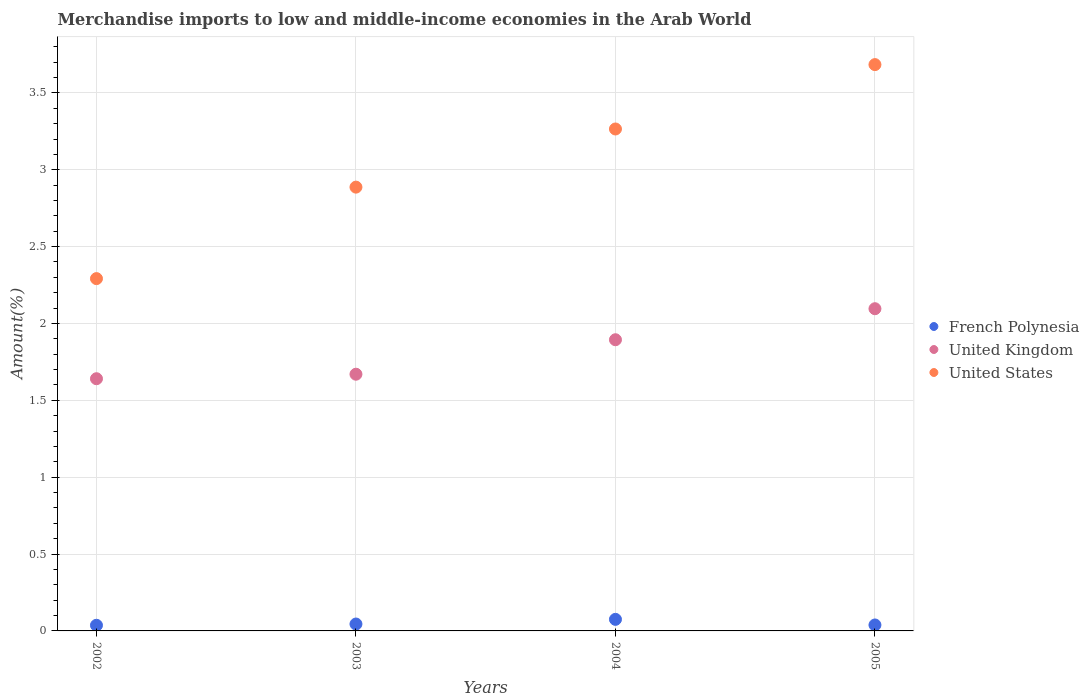What is the percentage of amount earned from merchandise imports in French Polynesia in 2002?
Provide a short and direct response. 0.04. Across all years, what is the maximum percentage of amount earned from merchandise imports in French Polynesia?
Offer a terse response. 0.08. Across all years, what is the minimum percentage of amount earned from merchandise imports in French Polynesia?
Provide a succinct answer. 0.04. In which year was the percentage of amount earned from merchandise imports in United Kingdom maximum?
Ensure brevity in your answer.  2005. What is the total percentage of amount earned from merchandise imports in United Kingdom in the graph?
Offer a terse response. 7.3. What is the difference between the percentage of amount earned from merchandise imports in United Kingdom in 2002 and that in 2004?
Offer a terse response. -0.25. What is the difference between the percentage of amount earned from merchandise imports in United States in 2004 and the percentage of amount earned from merchandise imports in French Polynesia in 2002?
Your response must be concise. 3.23. What is the average percentage of amount earned from merchandise imports in United Kingdom per year?
Your answer should be very brief. 1.83. In the year 2003, what is the difference between the percentage of amount earned from merchandise imports in United States and percentage of amount earned from merchandise imports in United Kingdom?
Offer a very short reply. 1.22. In how many years, is the percentage of amount earned from merchandise imports in United Kingdom greater than 0.9 %?
Ensure brevity in your answer.  4. What is the ratio of the percentage of amount earned from merchandise imports in French Polynesia in 2002 to that in 2003?
Offer a very short reply. 0.82. Is the difference between the percentage of amount earned from merchandise imports in United States in 2003 and 2004 greater than the difference between the percentage of amount earned from merchandise imports in United Kingdom in 2003 and 2004?
Offer a very short reply. No. What is the difference between the highest and the second highest percentage of amount earned from merchandise imports in French Polynesia?
Your response must be concise. 0.03. What is the difference between the highest and the lowest percentage of amount earned from merchandise imports in United States?
Keep it short and to the point. 1.39. Is the sum of the percentage of amount earned from merchandise imports in United States in 2003 and 2004 greater than the maximum percentage of amount earned from merchandise imports in French Polynesia across all years?
Ensure brevity in your answer.  Yes. Is it the case that in every year, the sum of the percentage of amount earned from merchandise imports in United Kingdom and percentage of amount earned from merchandise imports in French Polynesia  is greater than the percentage of amount earned from merchandise imports in United States?
Your answer should be compact. No. Is the percentage of amount earned from merchandise imports in United Kingdom strictly greater than the percentage of amount earned from merchandise imports in French Polynesia over the years?
Ensure brevity in your answer.  Yes. Is the percentage of amount earned from merchandise imports in United States strictly less than the percentage of amount earned from merchandise imports in United Kingdom over the years?
Keep it short and to the point. No. How many dotlines are there?
Give a very brief answer. 3. How many years are there in the graph?
Provide a succinct answer. 4. Does the graph contain grids?
Give a very brief answer. Yes. Where does the legend appear in the graph?
Keep it short and to the point. Center right. What is the title of the graph?
Your answer should be compact. Merchandise imports to low and middle-income economies in the Arab World. What is the label or title of the Y-axis?
Offer a very short reply. Amount(%). What is the Amount(%) of French Polynesia in 2002?
Provide a succinct answer. 0.04. What is the Amount(%) of United Kingdom in 2002?
Provide a succinct answer. 1.64. What is the Amount(%) in United States in 2002?
Your answer should be very brief. 2.29. What is the Amount(%) of French Polynesia in 2003?
Your answer should be very brief. 0.04. What is the Amount(%) of United Kingdom in 2003?
Provide a short and direct response. 1.67. What is the Amount(%) in United States in 2003?
Provide a succinct answer. 2.89. What is the Amount(%) in French Polynesia in 2004?
Offer a terse response. 0.08. What is the Amount(%) in United Kingdom in 2004?
Make the answer very short. 1.89. What is the Amount(%) in United States in 2004?
Offer a very short reply. 3.27. What is the Amount(%) in French Polynesia in 2005?
Give a very brief answer. 0.04. What is the Amount(%) of United Kingdom in 2005?
Provide a short and direct response. 2.1. What is the Amount(%) in United States in 2005?
Make the answer very short. 3.68. Across all years, what is the maximum Amount(%) of French Polynesia?
Keep it short and to the point. 0.08. Across all years, what is the maximum Amount(%) in United Kingdom?
Ensure brevity in your answer.  2.1. Across all years, what is the maximum Amount(%) of United States?
Ensure brevity in your answer.  3.68. Across all years, what is the minimum Amount(%) in French Polynesia?
Provide a short and direct response. 0.04. Across all years, what is the minimum Amount(%) of United Kingdom?
Your answer should be very brief. 1.64. Across all years, what is the minimum Amount(%) of United States?
Your answer should be very brief. 2.29. What is the total Amount(%) in French Polynesia in the graph?
Provide a succinct answer. 0.2. What is the total Amount(%) of United Kingdom in the graph?
Your answer should be very brief. 7.3. What is the total Amount(%) in United States in the graph?
Offer a terse response. 12.13. What is the difference between the Amount(%) of French Polynesia in 2002 and that in 2003?
Make the answer very short. -0.01. What is the difference between the Amount(%) in United Kingdom in 2002 and that in 2003?
Provide a short and direct response. -0.03. What is the difference between the Amount(%) of United States in 2002 and that in 2003?
Your answer should be very brief. -0.6. What is the difference between the Amount(%) in French Polynesia in 2002 and that in 2004?
Offer a very short reply. -0.04. What is the difference between the Amount(%) of United Kingdom in 2002 and that in 2004?
Offer a very short reply. -0.25. What is the difference between the Amount(%) in United States in 2002 and that in 2004?
Provide a short and direct response. -0.97. What is the difference between the Amount(%) in French Polynesia in 2002 and that in 2005?
Your answer should be very brief. -0. What is the difference between the Amount(%) of United Kingdom in 2002 and that in 2005?
Offer a very short reply. -0.46. What is the difference between the Amount(%) of United States in 2002 and that in 2005?
Provide a short and direct response. -1.39. What is the difference between the Amount(%) of French Polynesia in 2003 and that in 2004?
Provide a short and direct response. -0.03. What is the difference between the Amount(%) in United Kingdom in 2003 and that in 2004?
Provide a short and direct response. -0.22. What is the difference between the Amount(%) in United States in 2003 and that in 2004?
Offer a terse response. -0.38. What is the difference between the Amount(%) in French Polynesia in 2003 and that in 2005?
Keep it short and to the point. 0.01. What is the difference between the Amount(%) of United Kingdom in 2003 and that in 2005?
Provide a succinct answer. -0.43. What is the difference between the Amount(%) of United States in 2003 and that in 2005?
Provide a short and direct response. -0.8. What is the difference between the Amount(%) in French Polynesia in 2004 and that in 2005?
Keep it short and to the point. 0.04. What is the difference between the Amount(%) of United Kingdom in 2004 and that in 2005?
Keep it short and to the point. -0.2. What is the difference between the Amount(%) of United States in 2004 and that in 2005?
Offer a very short reply. -0.42. What is the difference between the Amount(%) in French Polynesia in 2002 and the Amount(%) in United Kingdom in 2003?
Provide a succinct answer. -1.63. What is the difference between the Amount(%) in French Polynesia in 2002 and the Amount(%) in United States in 2003?
Make the answer very short. -2.85. What is the difference between the Amount(%) of United Kingdom in 2002 and the Amount(%) of United States in 2003?
Provide a succinct answer. -1.25. What is the difference between the Amount(%) of French Polynesia in 2002 and the Amount(%) of United Kingdom in 2004?
Ensure brevity in your answer.  -1.86. What is the difference between the Amount(%) in French Polynesia in 2002 and the Amount(%) in United States in 2004?
Your response must be concise. -3.23. What is the difference between the Amount(%) of United Kingdom in 2002 and the Amount(%) of United States in 2004?
Your response must be concise. -1.62. What is the difference between the Amount(%) in French Polynesia in 2002 and the Amount(%) in United Kingdom in 2005?
Provide a succinct answer. -2.06. What is the difference between the Amount(%) in French Polynesia in 2002 and the Amount(%) in United States in 2005?
Make the answer very short. -3.65. What is the difference between the Amount(%) of United Kingdom in 2002 and the Amount(%) of United States in 2005?
Offer a terse response. -2.04. What is the difference between the Amount(%) of French Polynesia in 2003 and the Amount(%) of United Kingdom in 2004?
Your answer should be compact. -1.85. What is the difference between the Amount(%) in French Polynesia in 2003 and the Amount(%) in United States in 2004?
Offer a terse response. -3.22. What is the difference between the Amount(%) in United Kingdom in 2003 and the Amount(%) in United States in 2004?
Make the answer very short. -1.6. What is the difference between the Amount(%) in French Polynesia in 2003 and the Amount(%) in United Kingdom in 2005?
Give a very brief answer. -2.05. What is the difference between the Amount(%) in French Polynesia in 2003 and the Amount(%) in United States in 2005?
Keep it short and to the point. -3.64. What is the difference between the Amount(%) of United Kingdom in 2003 and the Amount(%) of United States in 2005?
Give a very brief answer. -2.01. What is the difference between the Amount(%) in French Polynesia in 2004 and the Amount(%) in United Kingdom in 2005?
Keep it short and to the point. -2.02. What is the difference between the Amount(%) in French Polynesia in 2004 and the Amount(%) in United States in 2005?
Provide a short and direct response. -3.61. What is the difference between the Amount(%) in United Kingdom in 2004 and the Amount(%) in United States in 2005?
Your answer should be very brief. -1.79. What is the average Amount(%) of French Polynesia per year?
Ensure brevity in your answer.  0.05. What is the average Amount(%) of United Kingdom per year?
Your response must be concise. 1.83. What is the average Amount(%) in United States per year?
Offer a terse response. 3.03. In the year 2002, what is the difference between the Amount(%) of French Polynesia and Amount(%) of United Kingdom?
Ensure brevity in your answer.  -1.6. In the year 2002, what is the difference between the Amount(%) in French Polynesia and Amount(%) in United States?
Offer a terse response. -2.26. In the year 2002, what is the difference between the Amount(%) of United Kingdom and Amount(%) of United States?
Your response must be concise. -0.65. In the year 2003, what is the difference between the Amount(%) in French Polynesia and Amount(%) in United Kingdom?
Provide a short and direct response. -1.63. In the year 2003, what is the difference between the Amount(%) in French Polynesia and Amount(%) in United States?
Keep it short and to the point. -2.84. In the year 2003, what is the difference between the Amount(%) of United Kingdom and Amount(%) of United States?
Provide a succinct answer. -1.22. In the year 2004, what is the difference between the Amount(%) in French Polynesia and Amount(%) in United Kingdom?
Provide a succinct answer. -1.82. In the year 2004, what is the difference between the Amount(%) in French Polynesia and Amount(%) in United States?
Make the answer very short. -3.19. In the year 2004, what is the difference between the Amount(%) in United Kingdom and Amount(%) in United States?
Offer a very short reply. -1.37. In the year 2005, what is the difference between the Amount(%) in French Polynesia and Amount(%) in United Kingdom?
Give a very brief answer. -2.06. In the year 2005, what is the difference between the Amount(%) of French Polynesia and Amount(%) of United States?
Ensure brevity in your answer.  -3.65. In the year 2005, what is the difference between the Amount(%) of United Kingdom and Amount(%) of United States?
Keep it short and to the point. -1.59. What is the ratio of the Amount(%) in French Polynesia in 2002 to that in 2003?
Give a very brief answer. 0.82. What is the ratio of the Amount(%) in United Kingdom in 2002 to that in 2003?
Keep it short and to the point. 0.98. What is the ratio of the Amount(%) of United States in 2002 to that in 2003?
Your response must be concise. 0.79. What is the ratio of the Amount(%) of French Polynesia in 2002 to that in 2004?
Offer a terse response. 0.49. What is the ratio of the Amount(%) of United Kingdom in 2002 to that in 2004?
Make the answer very short. 0.87. What is the ratio of the Amount(%) in United States in 2002 to that in 2004?
Make the answer very short. 0.7. What is the ratio of the Amount(%) of French Polynesia in 2002 to that in 2005?
Keep it short and to the point. 0.95. What is the ratio of the Amount(%) of United Kingdom in 2002 to that in 2005?
Your answer should be compact. 0.78. What is the ratio of the Amount(%) of United States in 2002 to that in 2005?
Provide a short and direct response. 0.62. What is the ratio of the Amount(%) in French Polynesia in 2003 to that in 2004?
Provide a succinct answer. 0.6. What is the ratio of the Amount(%) in United Kingdom in 2003 to that in 2004?
Provide a short and direct response. 0.88. What is the ratio of the Amount(%) of United States in 2003 to that in 2004?
Your answer should be compact. 0.88. What is the ratio of the Amount(%) of French Polynesia in 2003 to that in 2005?
Your answer should be compact. 1.16. What is the ratio of the Amount(%) of United Kingdom in 2003 to that in 2005?
Keep it short and to the point. 0.8. What is the ratio of the Amount(%) of United States in 2003 to that in 2005?
Provide a short and direct response. 0.78. What is the ratio of the Amount(%) in French Polynesia in 2004 to that in 2005?
Provide a short and direct response. 1.94. What is the ratio of the Amount(%) in United Kingdom in 2004 to that in 2005?
Ensure brevity in your answer.  0.9. What is the ratio of the Amount(%) of United States in 2004 to that in 2005?
Offer a very short reply. 0.89. What is the difference between the highest and the second highest Amount(%) of French Polynesia?
Your response must be concise. 0.03. What is the difference between the highest and the second highest Amount(%) in United Kingdom?
Provide a succinct answer. 0.2. What is the difference between the highest and the second highest Amount(%) of United States?
Offer a terse response. 0.42. What is the difference between the highest and the lowest Amount(%) in French Polynesia?
Give a very brief answer. 0.04. What is the difference between the highest and the lowest Amount(%) of United Kingdom?
Your answer should be compact. 0.46. What is the difference between the highest and the lowest Amount(%) of United States?
Provide a succinct answer. 1.39. 